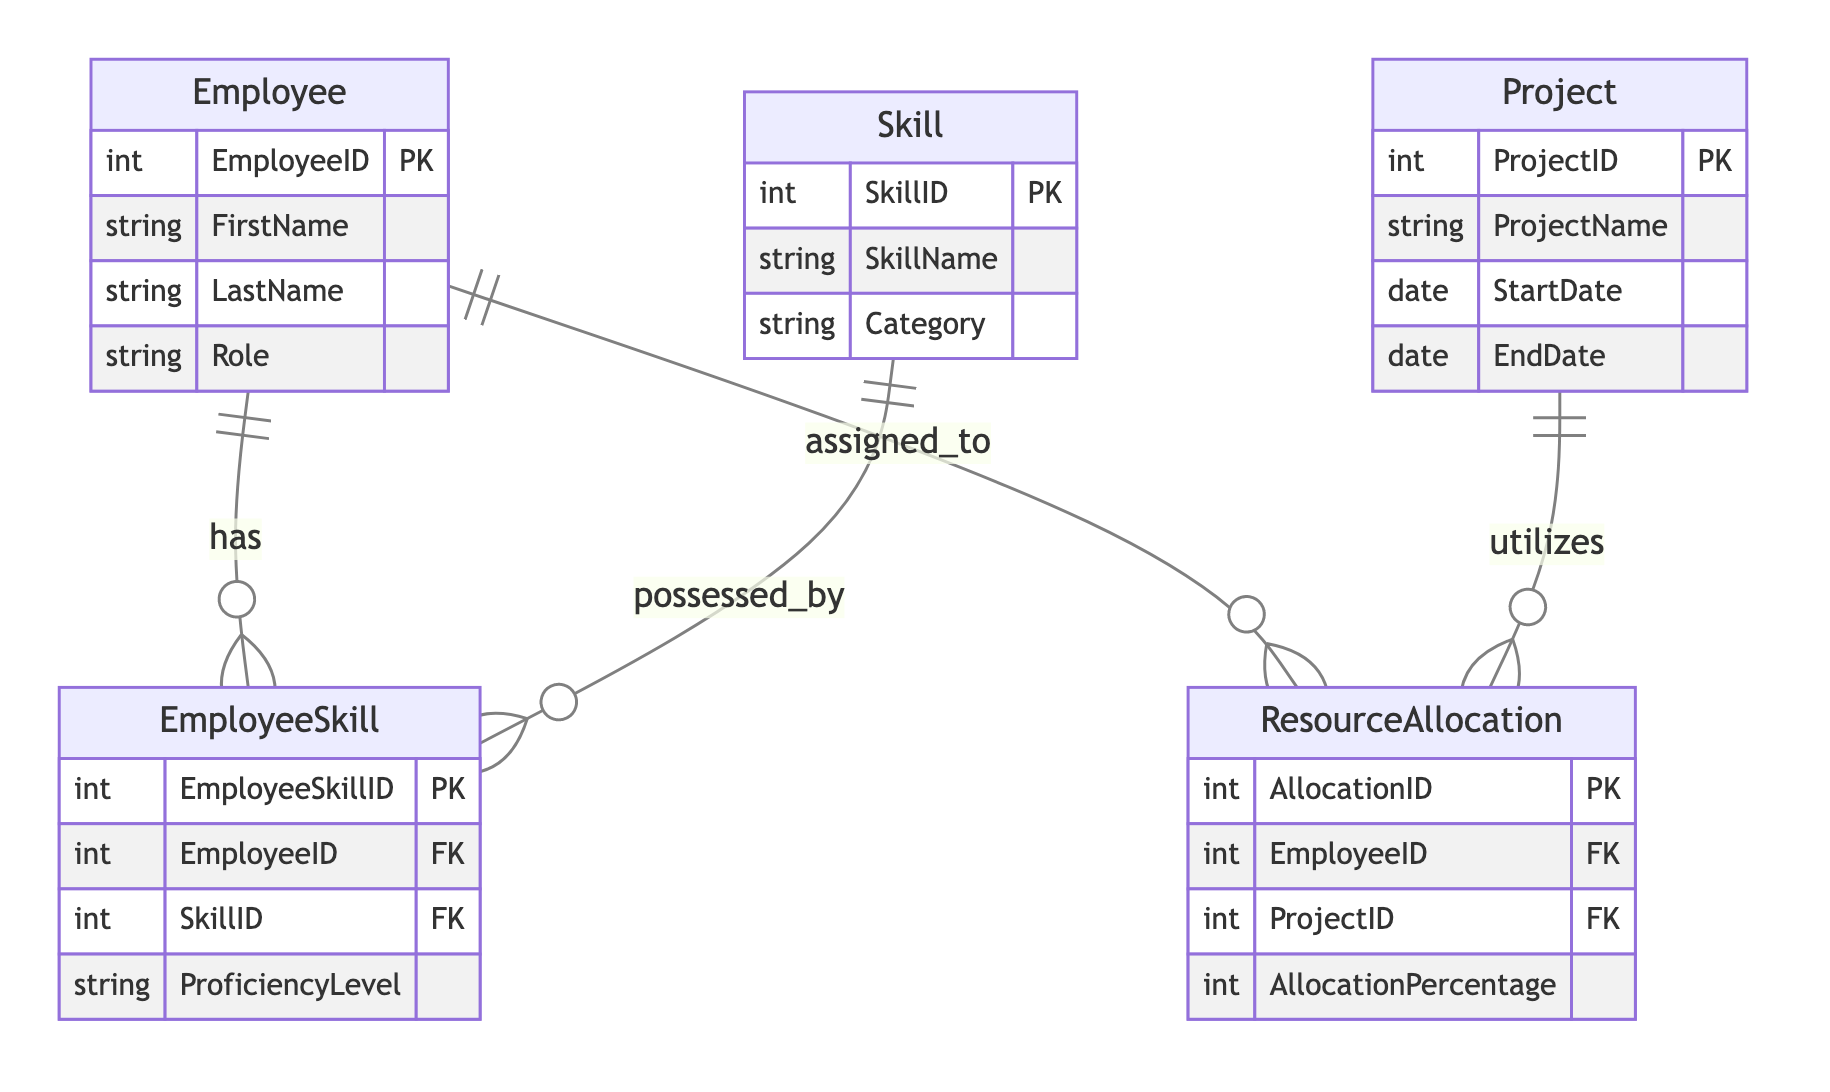What is the primary key of the Employee entity? The primary key of the Employee entity is EmployeeID, which uniquely identifies each employee in the system. This is indicated in the diagram where EmployeeID is marked as the primary key under the Employee entity.
Answer: EmployeeID How many attributes does the Skill entity have? The Skill entity has three attributes: SkillID, SkillName, and Category. These can be counted directly within the Skill entity section of the diagram.
Answer: Three What is the relationship type between Employee and Skill? The relationship type between Employee and Skill is ManyToMany, as indicated by the notation shown in the diagram connecting these two entities through the EmployeeSkill associative entity.
Answer: ManyToMany Which entity has a foreign key referencing ProjectID? The ResourceAllocation entity has a foreign key referencing ProjectID. This is specified in the attributes of ResourceAllocation, indicating that each allocation is associated with a specific project.
Answer: ResourceAllocation How many entities are present in the diagram? There are five entities present in the diagram: Employee, Skill, Project, ResourceAllocation, and EmployeeSkill. This can be verified by counting the distinct entities represented within the diagram.
Answer: Five What is the proficiency level associated with EmployeeSkill? The proficiency level associated with EmployeeSkill is identified as a string attribute that indicates how skilled an employee is in a particular skill. This is detailed in the EmployeeSkill entity section of the diagram.
Answer: ProficiencyLevel How do Employees get allocated to Projects? Employees get allocated to projects through the ResourceAllocation entity, which serves as an associative relationship between Employee and Project, indicating the percentage of their time allocated to those projects.
Answer: ResourceAllocation Name the relationship that connects Employee to Project. The relationship that connects Employee to Project is called WorksOn, as stated in the relationships section of the diagram that defines the interaction between these two entities.
Answer: WorksOn What attribute of Project indicates its time frame? The attributes StartDate and EndDate of the Project entity indicate its time frame, as they specify when the project begins and when it ends. Both attributes are listed under the Project entity in the diagram.
Answer: StartDate and EndDate 